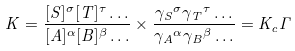Convert formula to latex. <formula><loc_0><loc_0><loc_500><loc_500>K = { \frac { [ S ] ^ { \sigma } [ T ] ^ { \tau } \dots } { [ A ] ^ { \alpha } [ B ] ^ { \beta } \dots } } \times { \frac { { \gamma _ { S } } ^ { \sigma } { \gamma _ { T } } ^ { \tau } \dots } { { \gamma _ { A } } ^ { \alpha } { \gamma _ { B } } ^ { \beta } \dots } } = K _ { c } \Gamma</formula> 